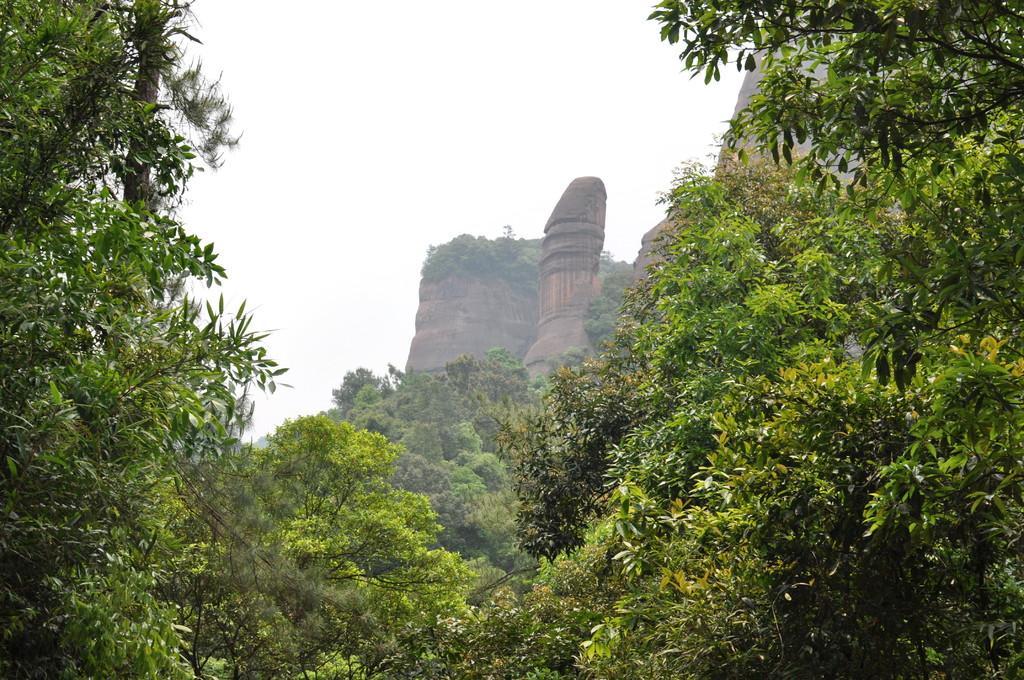Please provide a concise description of this image. In this picture we can see a few trees, hills and the sky. 